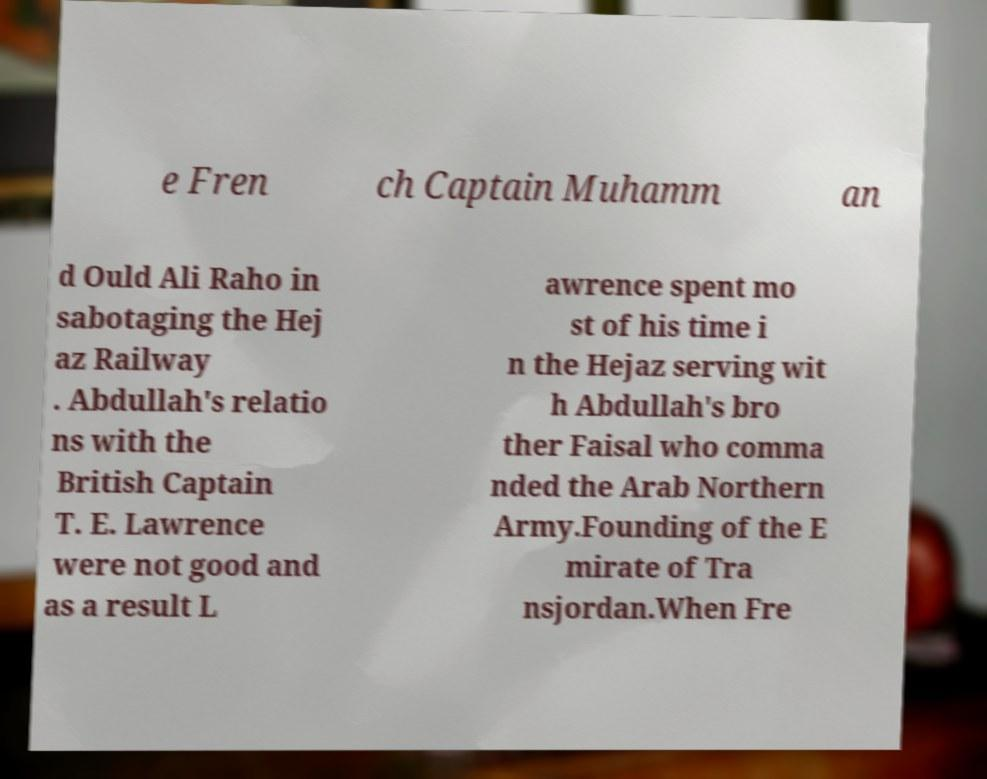Can you read and provide the text displayed in the image?This photo seems to have some interesting text. Can you extract and type it out for me? e Fren ch Captain Muhamm an d Ould Ali Raho in sabotaging the Hej az Railway . Abdullah's relatio ns with the British Captain T. E. Lawrence were not good and as a result L awrence spent mo st of his time i n the Hejaz serving wit h Abdullah's bro ther Faisal who comma nded the Arab Northern Army.Founding of the E mirate of Tra nsjordan.When Fre 